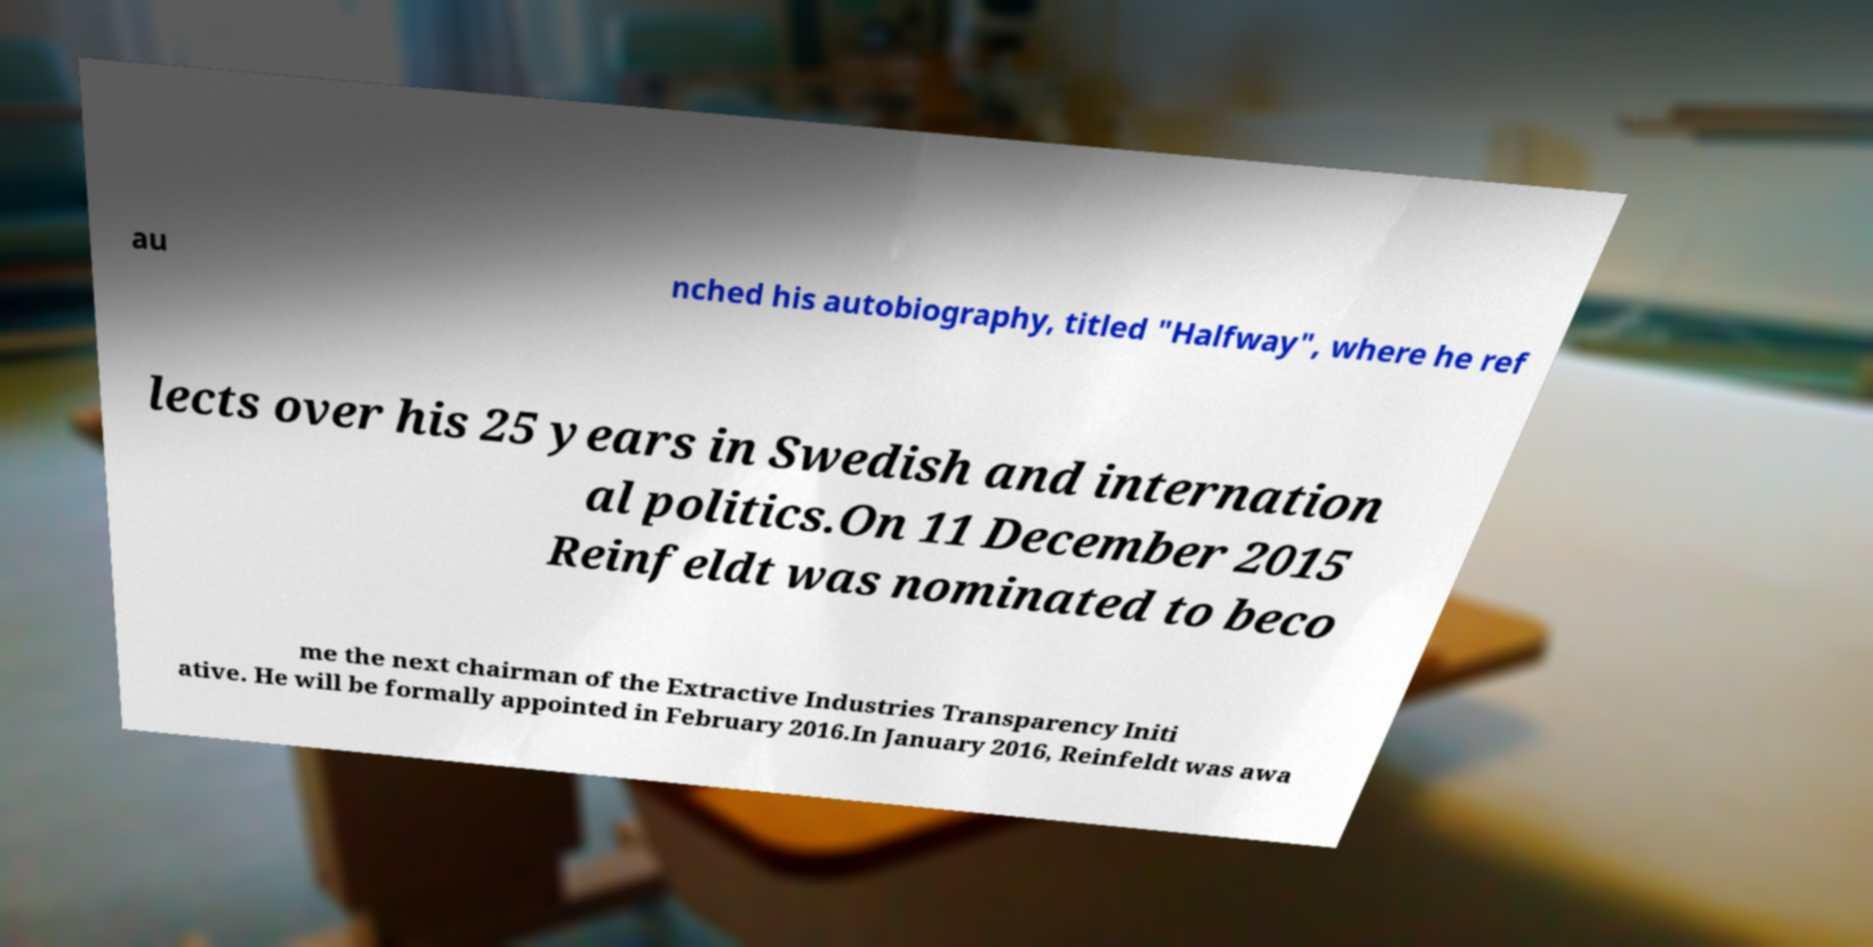Could you assist in decoding the text presented in this image and type it out clearly? au nched his autobiography, titled "Halfway", where he ref lects over his 25 years in Swedish and internation al politics.On 11 December 2015 Reinfeldt was nominated to beco me the next chairman of the Extractive Industries Transparency Initi ative. He will be formally appointed in February 2016.In January 2016, Reinfeldt was awa 